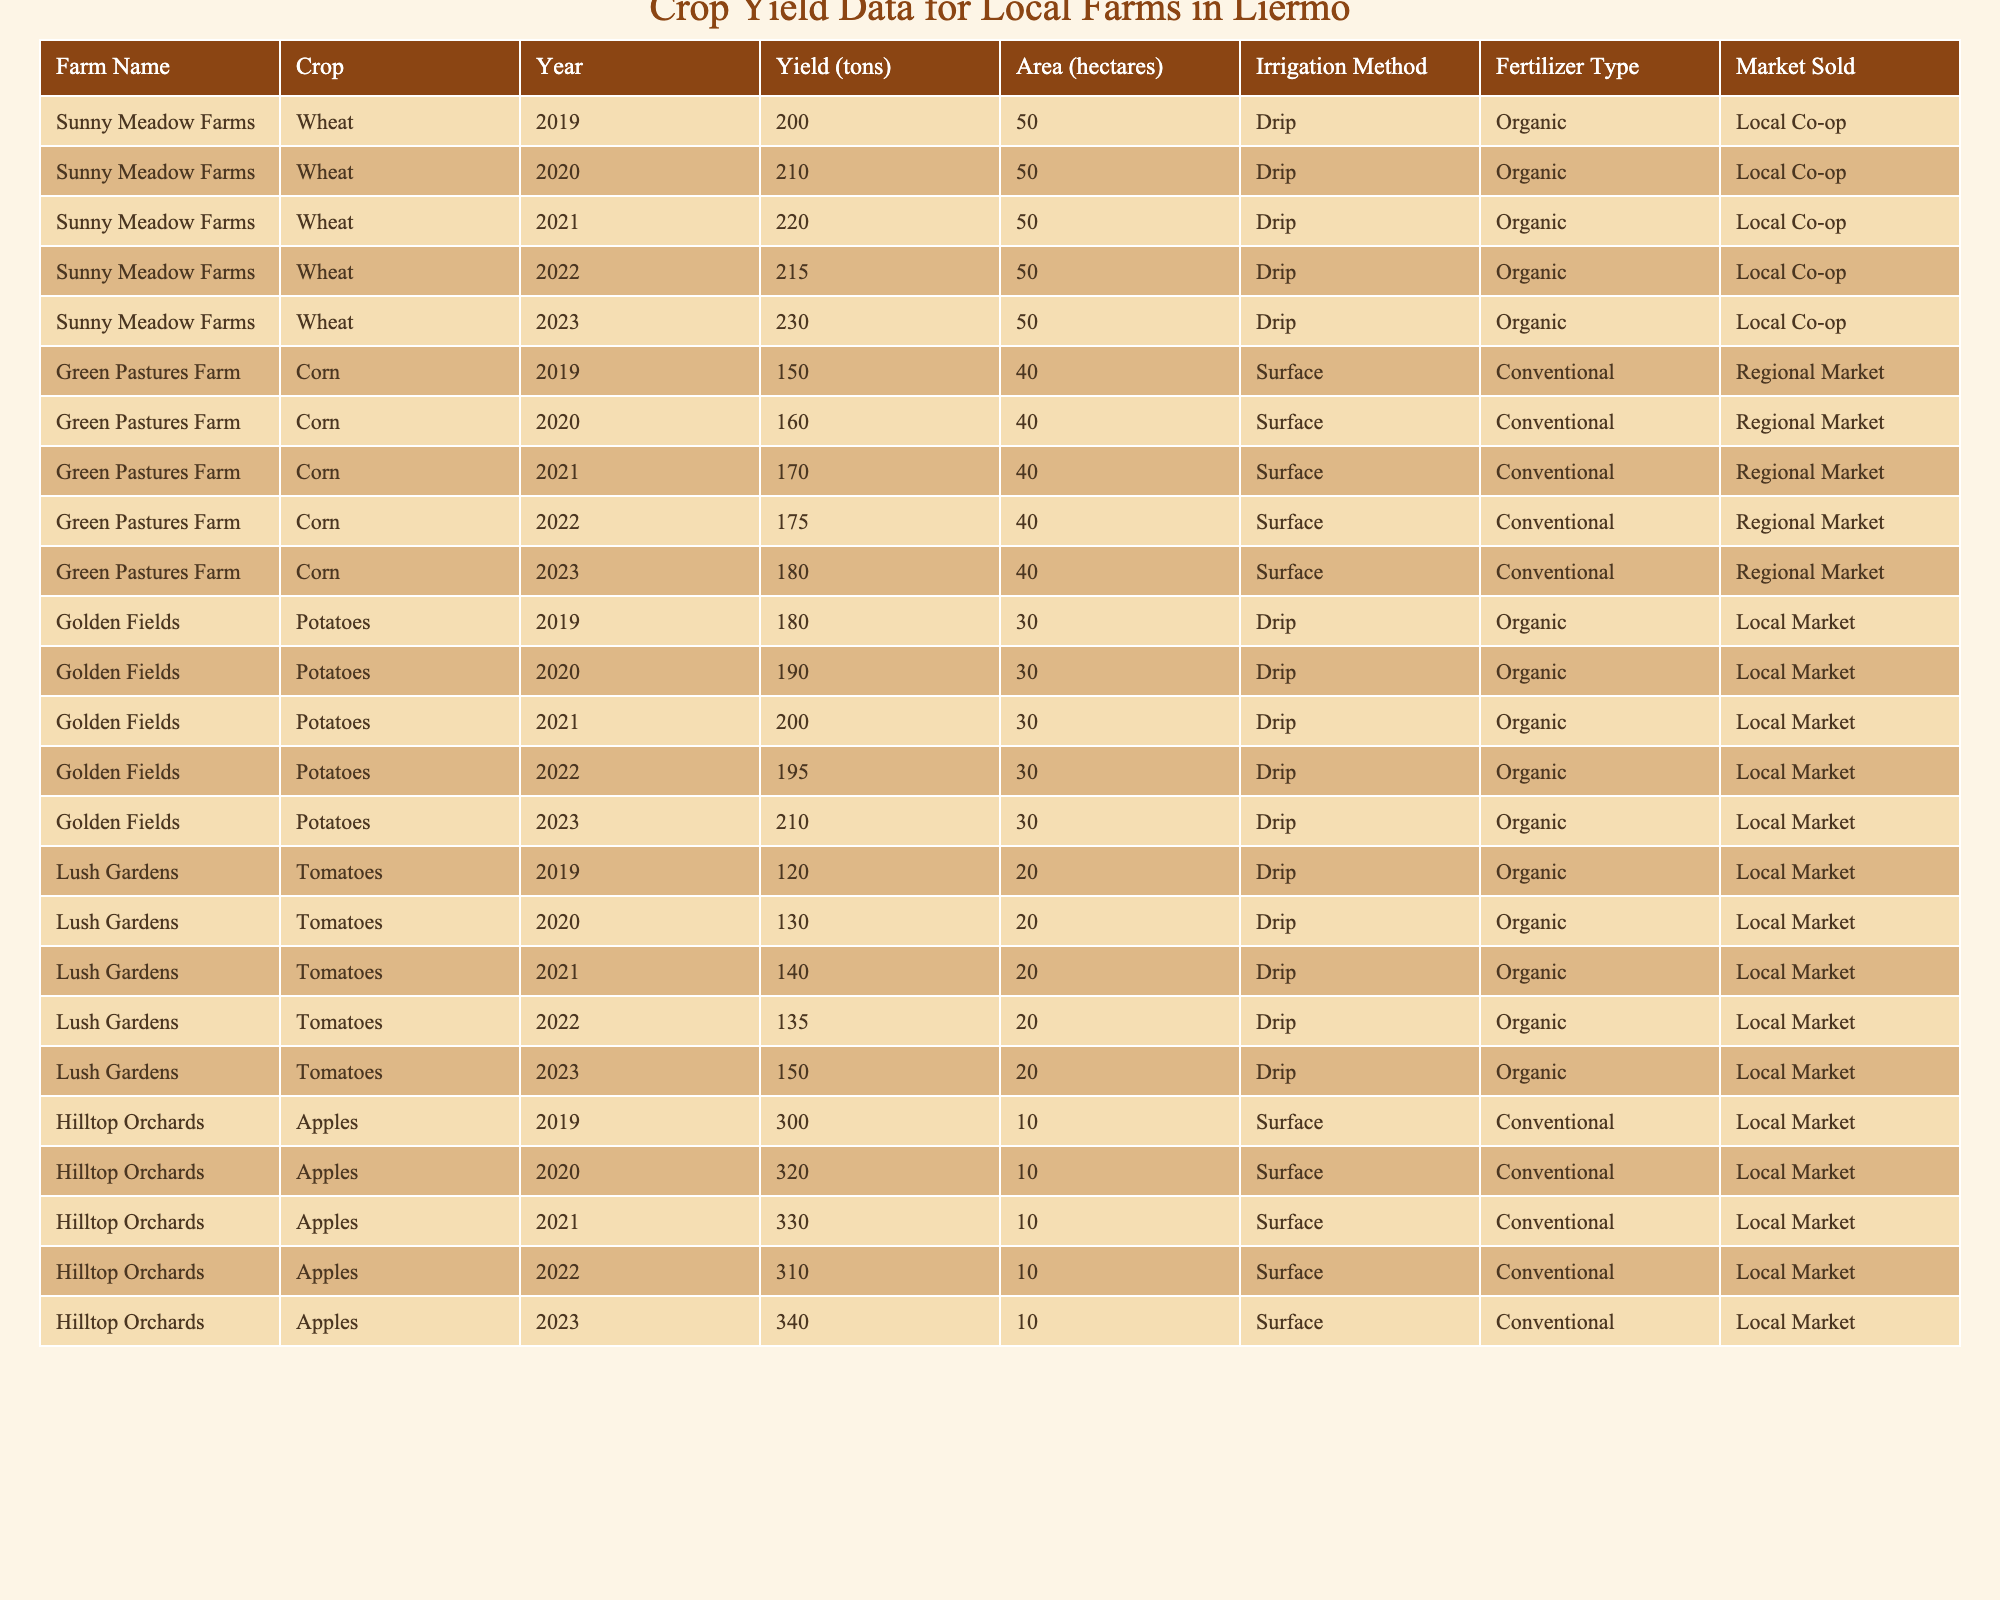What was the highest wheat yield recorded in Sunny Meadow Farms over the last five years? The table shows the wheat yields for Sunny Meadow Farms for the years 2019 to 2023. The yields are 200, 210, 220, 215, and 230 tons. The highest yield is 230 tons in 2023.
Answer: 230 tons Which farm produced the most potatoes in a single year? Looking at the data for Golden Fields, the potato yields from 2019 to 2023 are 180, 190, 200, 195, and 210 tons. The highest yield is 210 tons in 2023, making Golden Fields the farm with the highest single-year potato yield.
Answer: Golden Fields, 210 tons Did Lush Gardens have a decrease in tomato yield in any year? The tomato yields for Lush Gardens from 2019 to 2023 are 120, 130, 140, 135, and 150 tons. There is a decrease from 140 tons in 2021 to 135 tons in 2022, confirming that there was a decrease.
Answer: Yes What is the total apple yield from Hilltop Orchards over the last five years? The apple yields for Hilltop Orchards are 300, 320, 330, 310, and 340 tons. Summing these values gives: 300 + 320 + 330 + 310 + 340 = 1600 tons.
Answer: 1600 tons Was the average corn yield over the five years greater than 170 tons? The corn yields from Green Pastures Farm for the years 2019 to 2023 are 150, 160, 170, 175, and 180 tons. The total yield is 150 + 160 + 170 + 175 + 180 = 835 tons. The average yield is 835/5 = 167 tons, which is less than 170 tons.
Answer: No Which year saw the highest combined yield for all crops across all farms? To find the highest combined yield, we need to sum the yields for each year. For 2019: 200 (Wheat) + 150 (Corn) + 180 (Potatoes) + 120 (Tomatoes) + 300 (Apples) = 950 tons. For 2020: 210 + 160 + 190 + 130 + 320 = 1010 tons. For 2021: 220 + 170 + 200 + 140 + 330 = 1070 tons. For 2022: 215 + 175 + 195 + 135 + 310 = 1030 tons. For 2023: 230 + 180 + 210 + 150 + 340 = 1110 tons. The highest combined yield is in 2023 with 1110 tons.
Answer: 2023, 1110 tons What was the trend in wheat yield over the five years for Sunny Meadow Farms? The data shows the wheat yields for Sunny Meadow Farms were consistently increasing over the years: 200, 210, 220, 215, and then 230 tons. Hence, there is an upward trend with a slight dip in 2022 before rising again in 2023.
Answer: Increasing with a slight dip in 2022 